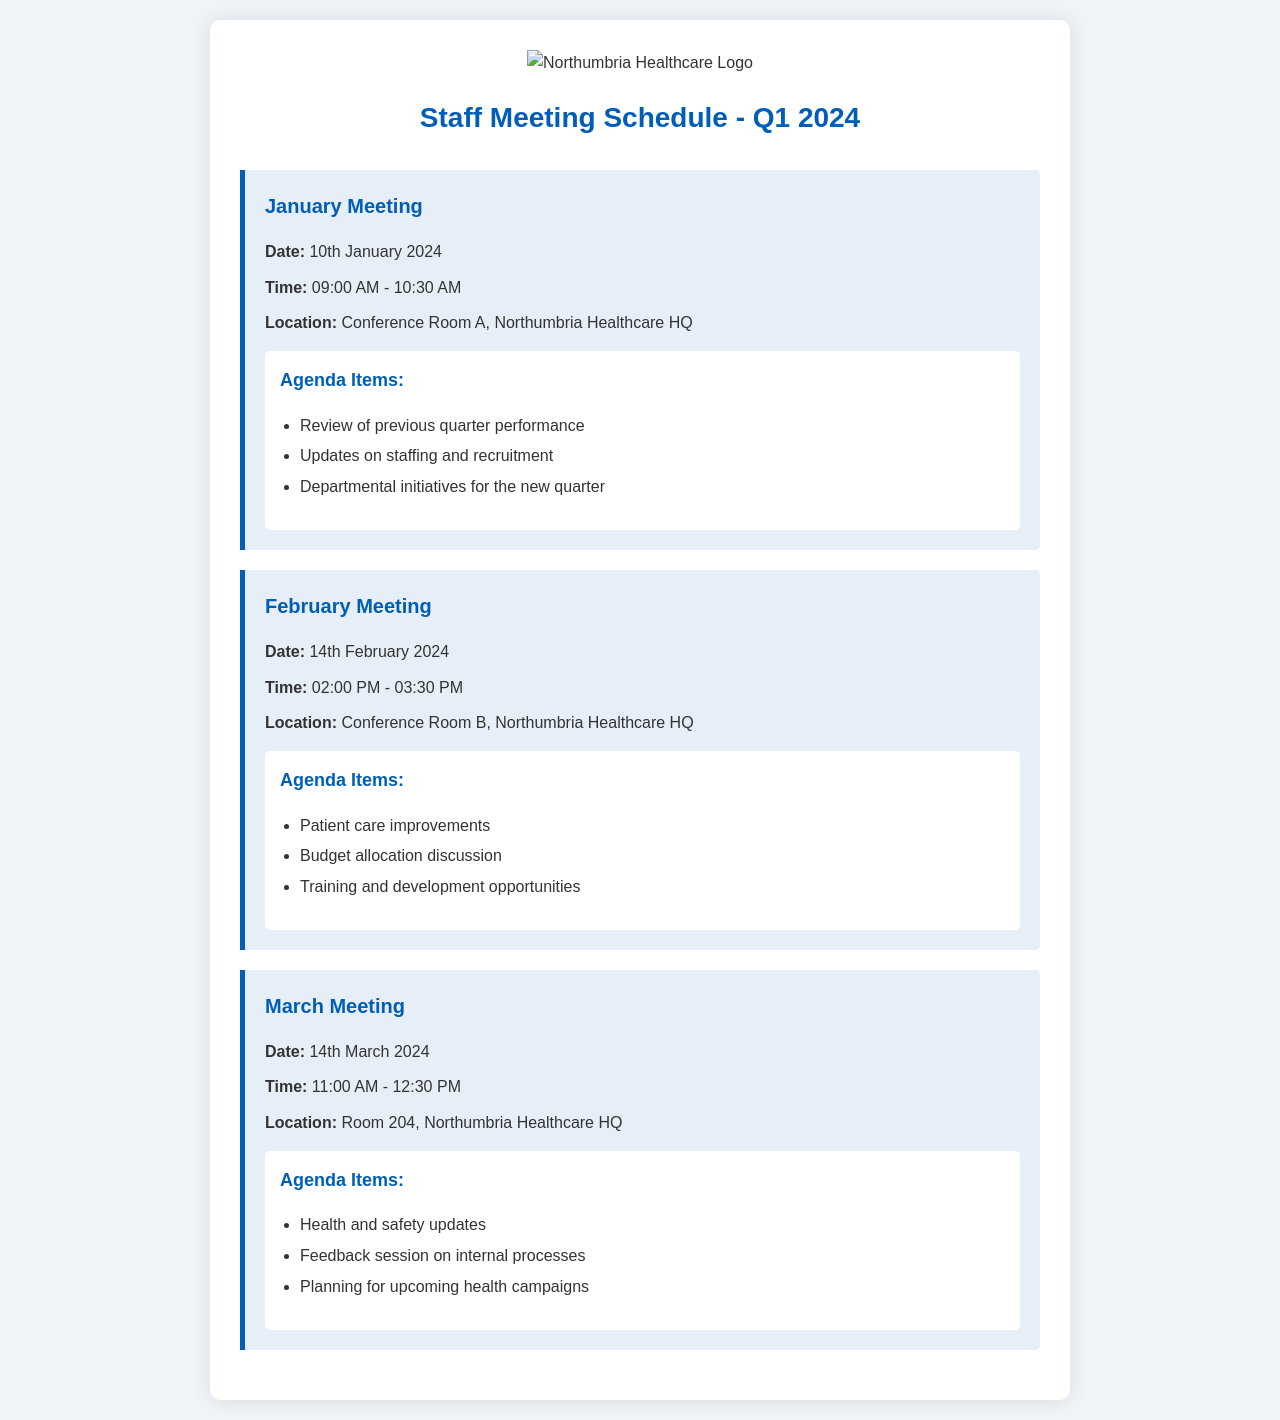What is the date of the January meeting? The date of the January meeting is specifically stated in the document.
Answer: 10th January 2024 What time does the February meeting start? The start time for the February meeting is mentioned in the meeting details.
Answer: 02:00 PM Where is the March meeting held? The location for the March meeting is listed in the document.
Answer: Room 204, Northumbria Healthcare HQ What is one agenda item for the January meeting? The document lists specific agenda items for each meeting including one from January.
Answer: Review of previous quarter performance Which meeting is scheduled after February? The order of the meetings can be determined by looking at the dates provided in the schedule.
Answer: March Meeting How long is the January meeting scheduled to last? The duration of the January meeting can be calculated by looking at the start and end times given.
Answer: 1 hour 30 minutes 